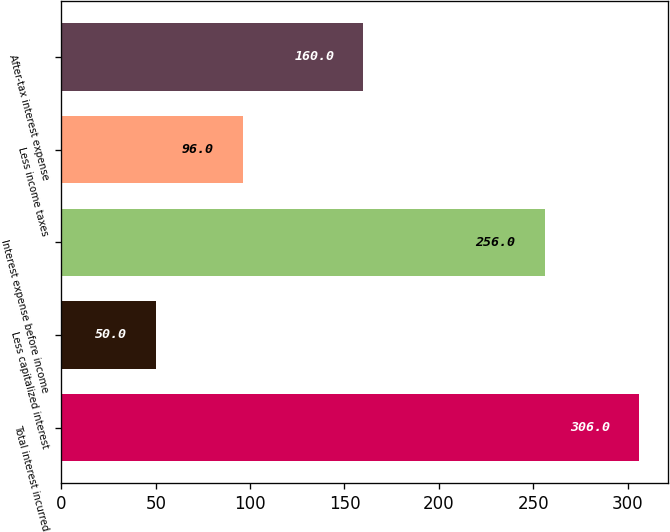Convert chart to OTSL. <chart><loc_0><loc_0><loc_500><loc_500><bar_chart><fcel>Total interest incurred<fcel>Less capitalized interest<fcel>Interest expense before income<fcel>Less income taxes<fcel>After-tax interest expense<nl><fcel>306<fcel>50<fcel>256<fcel>96<fcel>160<nl></chart> 